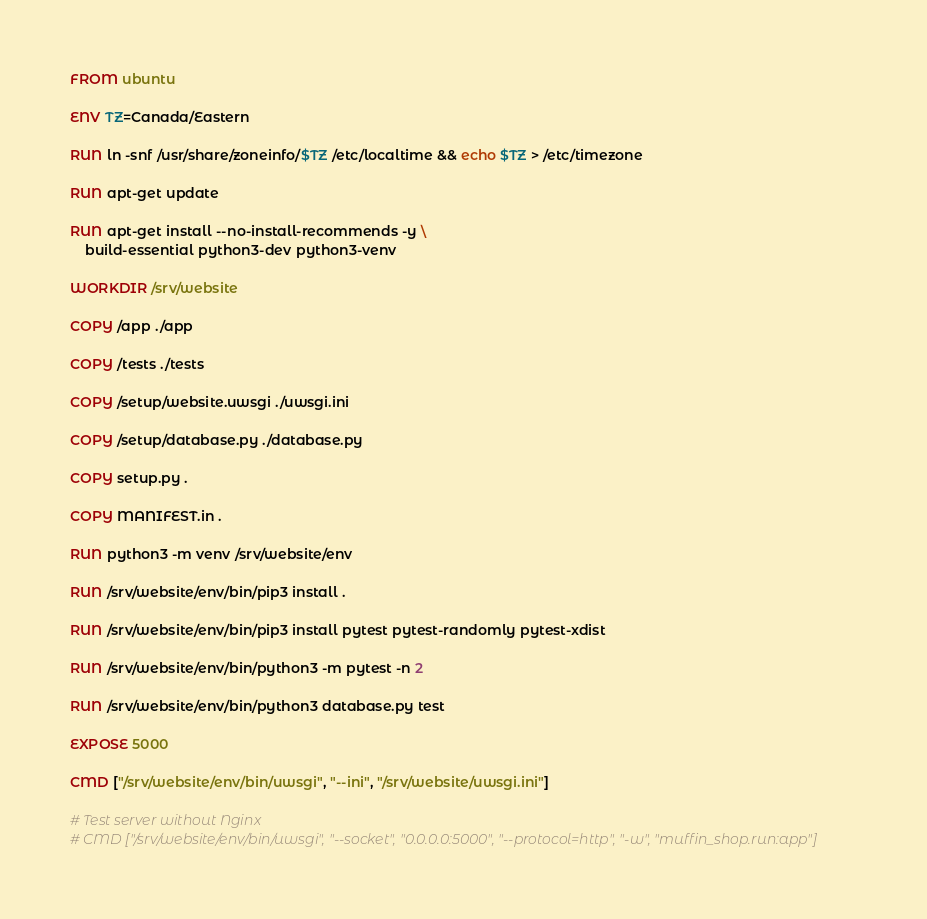<code> <loc_0><loc_0><loc_500><loc_500><_Dockerfile_>FROM ubuntu

ENV TZ=Canada/Eastern

RUN ln -snf /usr/share/zoneinfo/$TZ /etc/localtime && echo $TZ > /etc/timezone

RUN apt-get update

RUN apt-get install --no-install-recommends -y \
    build-essential python3-dev python3-venv

WORKDIR /srv/website

COPY /app ./app

COPY /tests ./tests

COPY /setup/website.uwsgi ./uwsgi.ini

COPY /setup/database.py ./database.py

COPY setup.py .

COPY MANIFEST.in .

RUN python3 -m venv /srv/website/env

RUN /srv/website/env/bin/pip3 install .

RUN /srv/website/env/bin/pip3 install pytest pytest-randomly pytest-xdist

RUN /srv/website/env/bin/python3 -m pytest -n 2

RUN /srv/website/env/bin/python3 database.py test

EXPOSE 5000

CMD ["/srv/website/env/bin/uwsgi", "--ini", "/srv/website/uwsgi.ini"]

# Test server without Nginx
# CMD ["/srv/website/env/bin/uwsgi", "--socket", "0.0.0.0:5000", "--protocol=http", "-w", "muffin_shop.run:app"]
</code> 